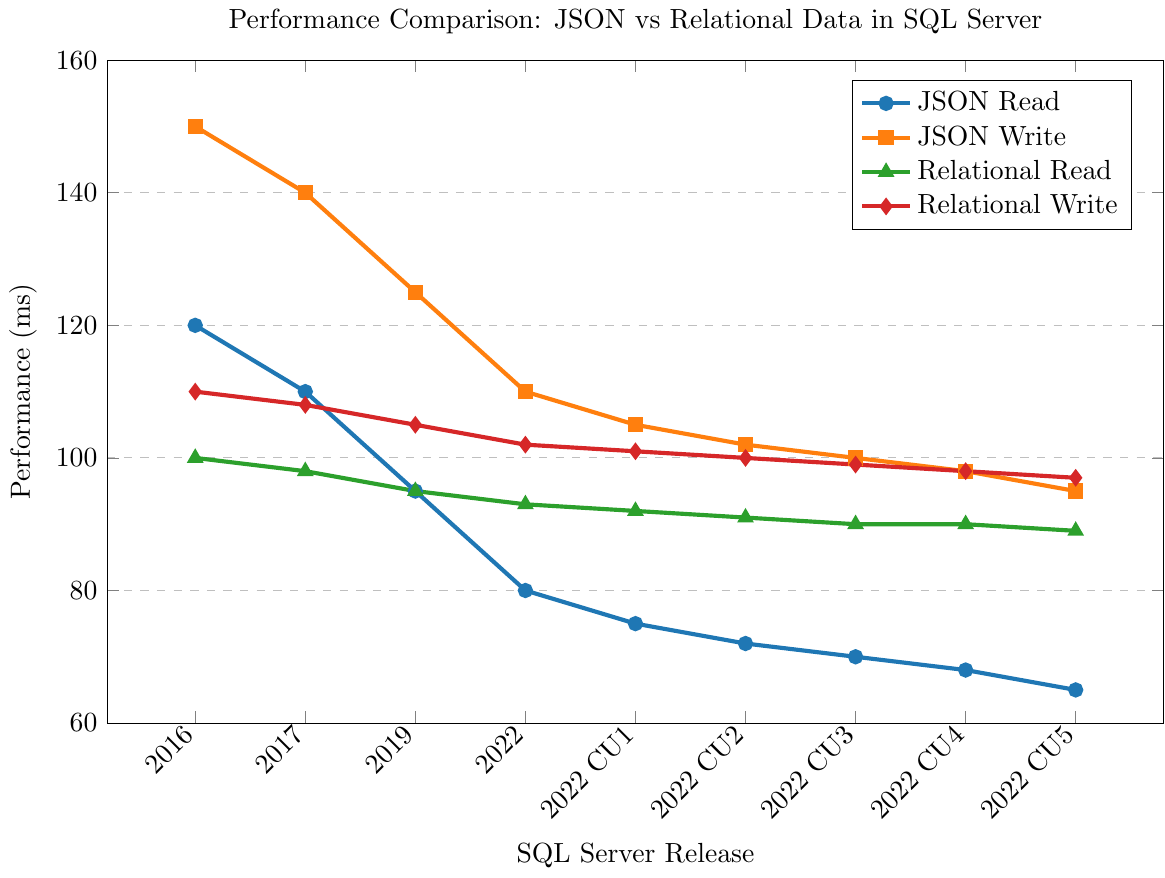Which SQL Server release has the fastest JSON read performance? The JSON read performance is represented by blue lines with circle markers. The lowest value indicates the fastest performance. By observing the blue line, SQL Server 2022 CU5 has the lowest JSON read time at 65 ms.
Answer: SQL Server 2022 CU5 In which release does relational write performance improve the most compared to the previous release? The relational write performance is shown by the red lines with diamond markers. By comparing each point to its previous one, the most significant improvement appears between SQL Server 2019 (105 ms) and SQL Server 2022 (102 ms), with a difference of 3 ms.
Answer: SQL Server 2022 What is the difference in JSON write performance between SQL Server 2016 and SQL Server 2022 CU2? JSON write performance is shown by the orange line with square markers. From the chart, JSON write time in SQL Server 2016 is 150 ms and in SQL Server 2022 CU2 is 102 ms. The difference is 150 ms - 102 ms.
Answer: 48 ms Which has lower read times: JSON or relational data in SQL Server 2022 CU3? For SQL Server 2022 CU3, refer to the corresponding markers. JSON read time (blue) is 70 ms, and relational read time (green) is 90 ms. So, JSON data has lower read times.
Answer: JSON How much did relational read performance improve from SQL Server 2016 to SQL Server 2022 CU5? To find the improvement, subtract the relational read time in SQL Server 2022 CU5 (89 ms) from that in SQL Server 2016 (100 ms). The improvement is 100 ms - 89 ms.
Answer: 11 ms In which SQL Server release does JSON write performance first reach below 100 ms? Observing the orange line with square markers, JSON write performance drops below 100 ms first at SQL Server 2022 CU3, with a write time of 98 ms.
Answer: SQL Server 2022 CU3 Compare the JSON read performance between SQL Server 2017 and SQL Server 2022 CU1. Which is faster and by how much? JSON read performance for SQL Server 2017 is 110 ms (blue line) and for SQL Server 2022 CU1 is 75 ms. The difference is 110 ms - 75 ms.
Answer: SQL Server 2022 CU1 by 35 ms What is the average performance time for relational writes across all versions? Add all the relational write times and divide by the number of versions: (110 + 108 + 105 + 102 + 101 + 100 + 99 + 98 + 97) / 9.
Answer: 102.22 ms Which release shows the largest improvement in JSON read performance compared to its predecessor? JSON read times are represented by the blue line. By observing the drops between consecutive points, the largest improvement is seen between SQL Server 2019 (95 ms) and SQL Server 2022 (80 ms), with a difference of 15 ms.
Answer: SQL Server 2022 